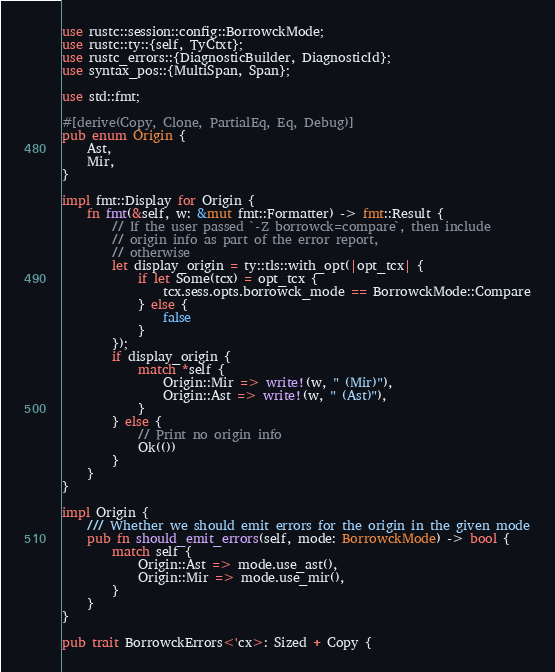Convert code to text. <code><loc_0><loc_0><loc_500><loc_500><_Rust_>use rustc::session::config::BorrowckMode;
use rustc::ty::{self, TyCtxt};
use rustc_errors::{DiagnosticBuilder, DiagnosticId};
use syntax_pos::{MultiSpan, Span};

use std::fmt;

#[derive(Copy, Clone, PartialEq, Eq, Debug)]
pub enum Origin {
    Ast,
    Mir,
}

impl fmt::Display for Origin {
    fn fmt(&self, w: &mut fmt::Formatter) -> fmt::Result {
        // If the user passed `-Z borrowck=compare`, then include
        // origin info as part of the error report,
        // otherwise
        let display_origin = ty::tls::with_opt(|opt_tcx| {
            if let Some(tcx) = opt_tcx {
                tcx.sess.opts.borrowck_mode == BorrowckMode::Compare
            } else {
                false
            }
        });
        if display_origin {
            match *self {
                Origin::Mir => write!(w, " (Mir)"),
                Origin::Ast => write!(w, " (Ast)"),
            }
        } else {
            // Print no origin info
            Ok(())
        }
    }
}

impl Origin {
    /// Whether we should emit errors for the origin in the given mode
    pub fn should_emit_errors(self, mode: BorrowckMode) -> bool {
        match self {
            Origin::Ast => mode.use_ast(),
            Origin::Mir => mode.use_mir(),
        }
    }
}

pub trait BorrowckErrors<'cx>: Sized + Copy {</code> 